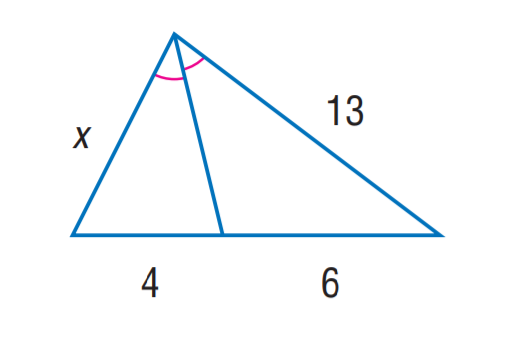Question: Find x.
Choices:
A. \frac { 4 } { 3 }
B. \frac { 13 } { 3 }
C. 6
D. \frac { 26 } { 3 }
Answer with the letter. Answer: D 